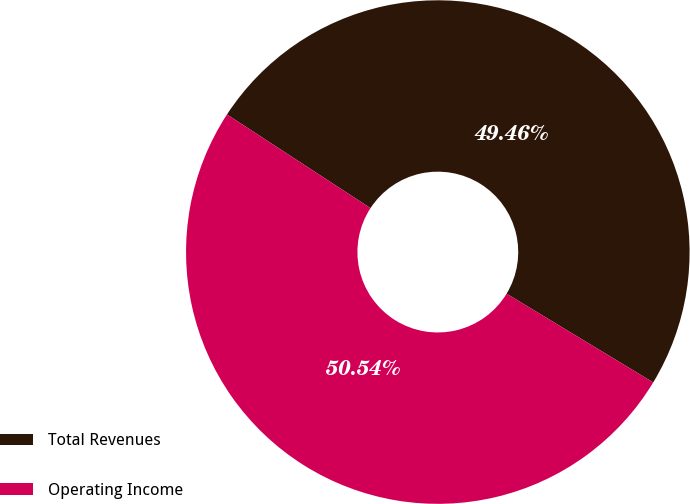Convert chart to OTSL. <chart><loc_0><loc_0><loc_500><loc_500><pie_chart><fcel>Total Revenues<fcel>Operating Income<nl><fcel>49.46%<fcel>50.54%<nl></chart> 